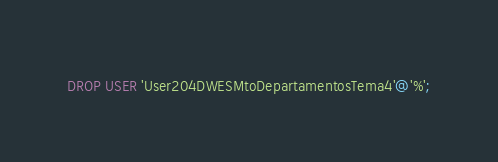<code> <loc_0><loc_0><loc_500><loc_500><_SQL_>DROP USER 'User204DWESMtoDepartamentosTema4'@'%';
</code> 